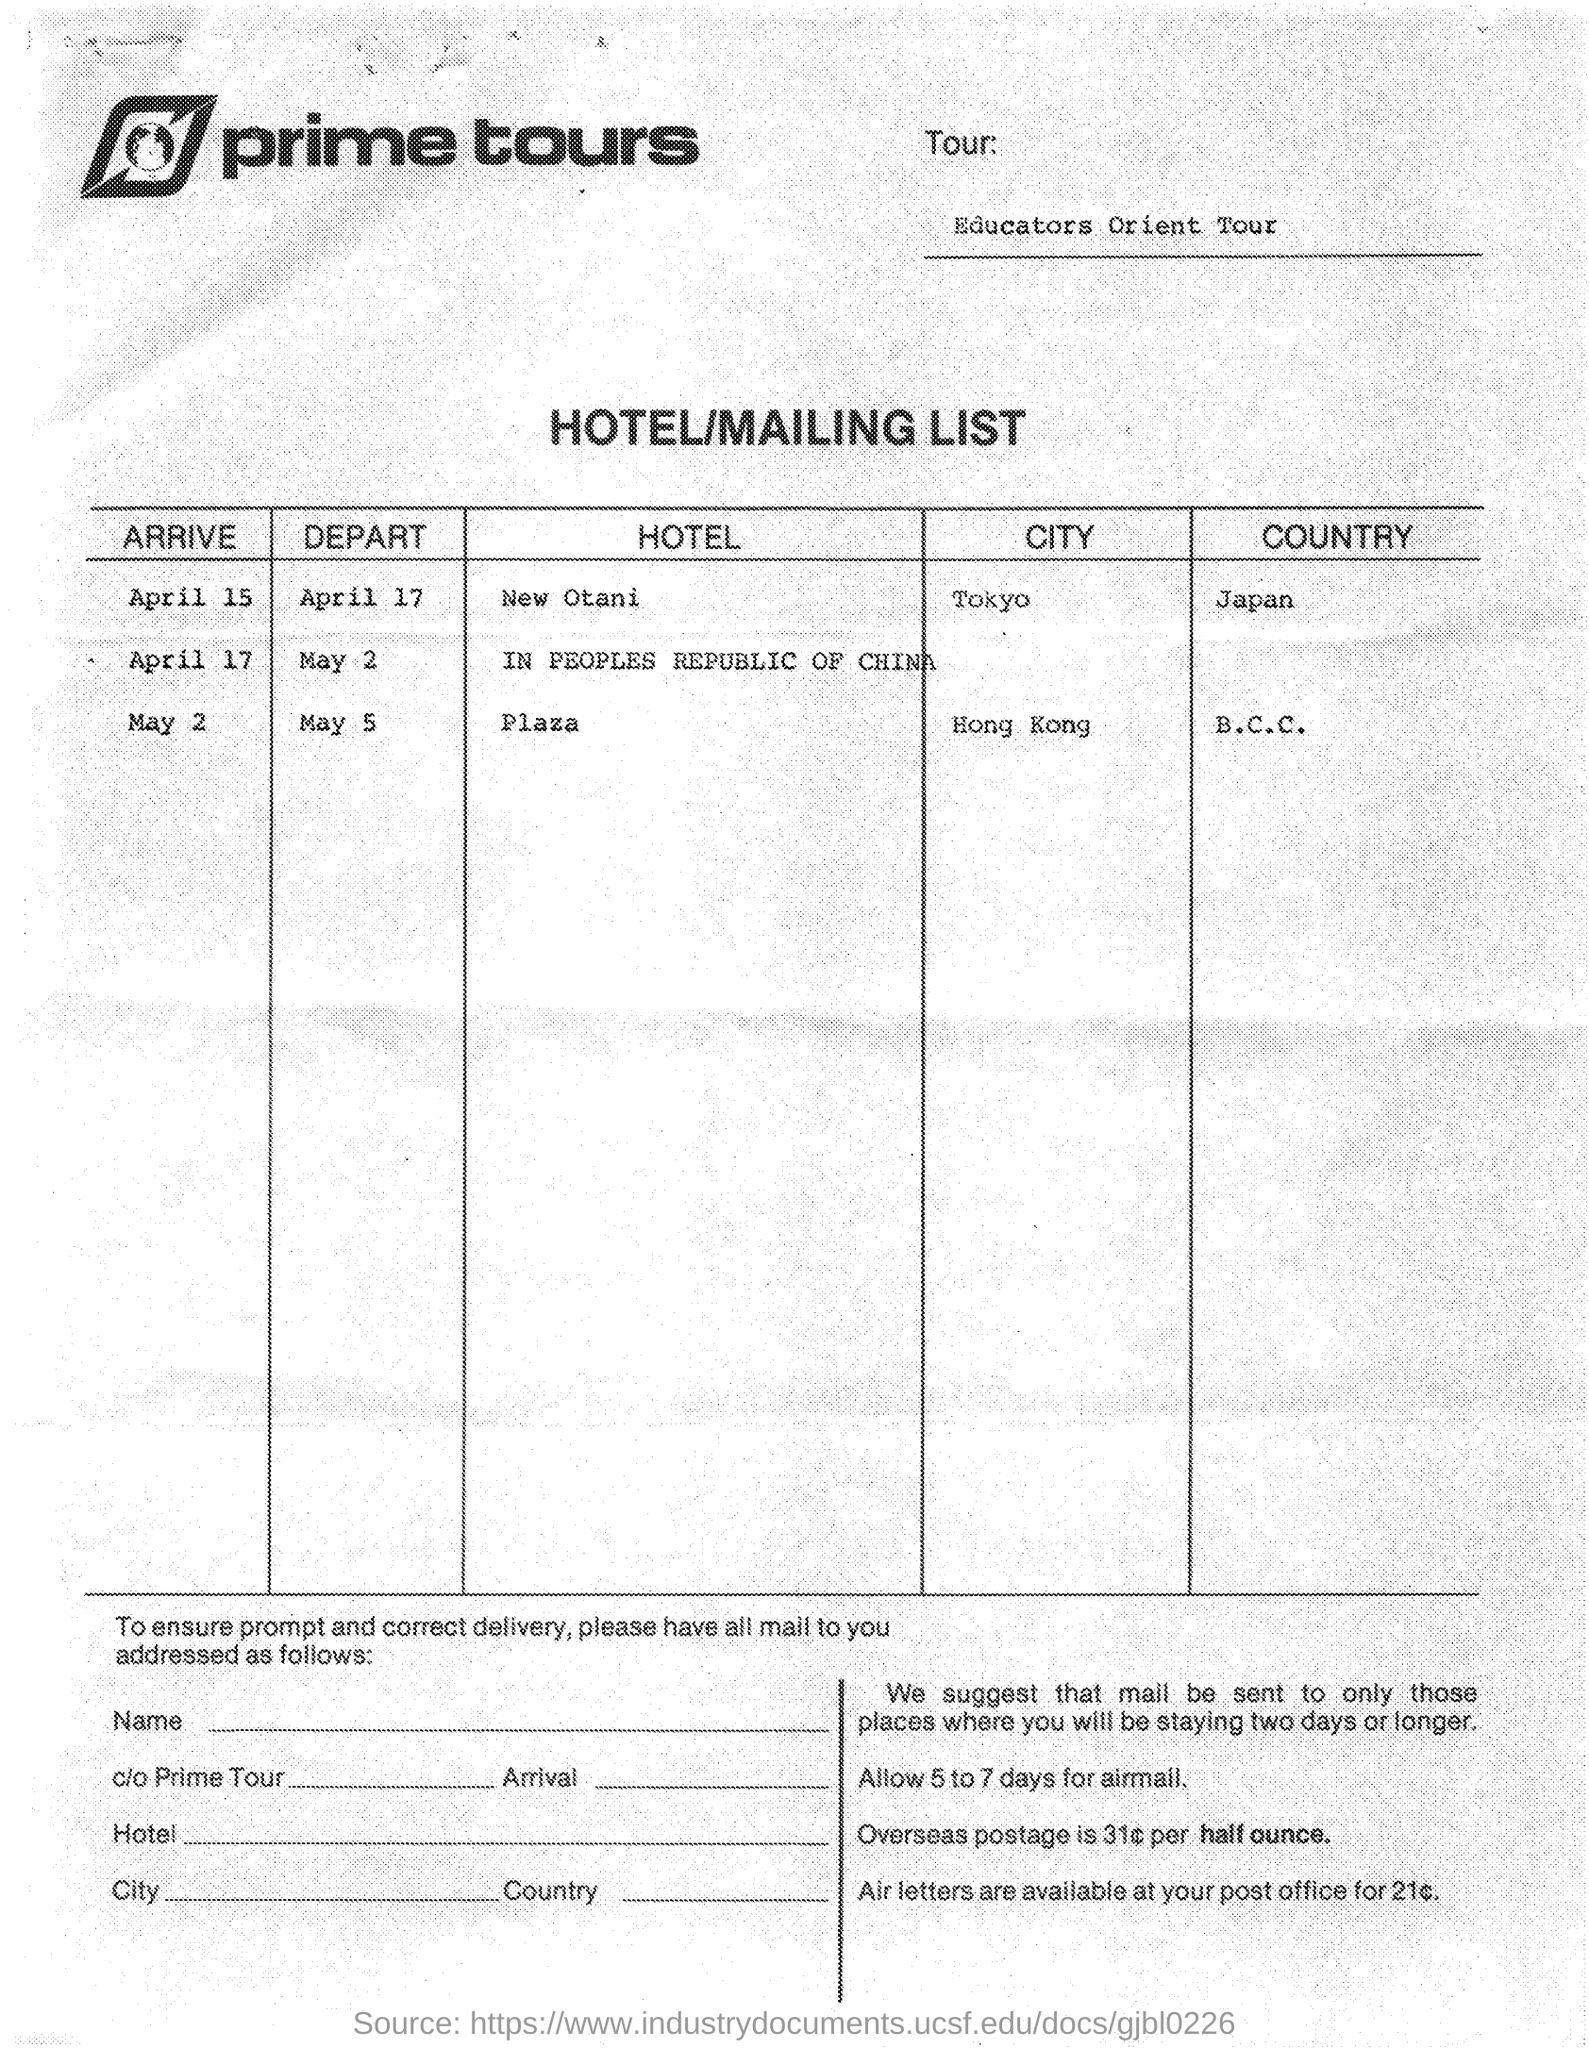What is name of tour company?
Keep it short and to the point. Prime tours. Which country is Hong Kong in?
Provide a short and direct response. B.C.C. Which country is tokyo in ?
Give a very brief answer. Japan. 